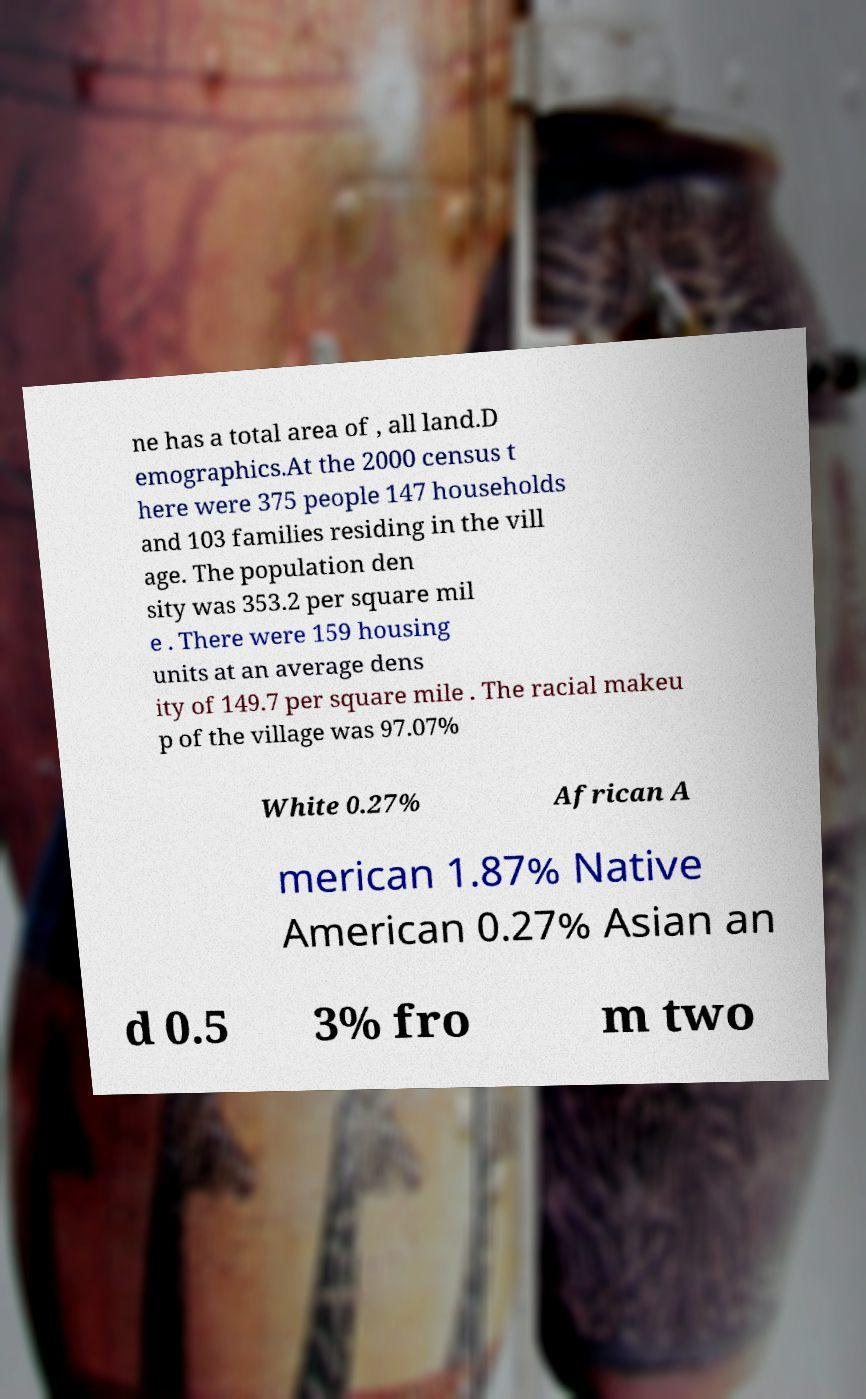Could you extract and type out the text from this image? ne has a total area of , all land.D emographics.At the 2000 census t here were 375 people 147 households and 103 families residing in the vill age. The population den sity was 353.2 per square mil e . There were 159 housing units at an average dens ity of 149.7 per square mile . The racial makeu p of the village was 97.07% White 0.27% African A merican 1.87% Native American 0.27% Asian an d 0.5 3% fro m two 